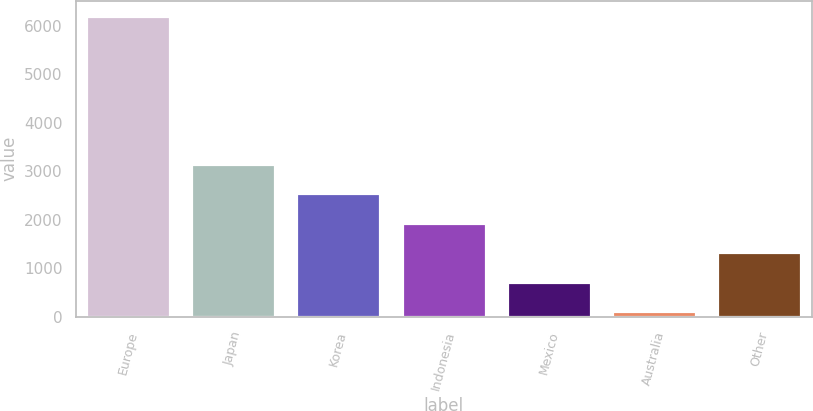<chart> <loc_0><loc_0><loc_500><loc_500><bar_chart><fcel>Europe<fcel>Japan<fcel>Korea<fcel>Indonesia<fcel>Mexico<fcel>Australia<fcel>Other<nl><fcel>6209<fcel>3159.5<fcel>2549.6<fcel>1939.7<fcel>719.9<fcel>110<fcel>1329.8<nl></chart> 